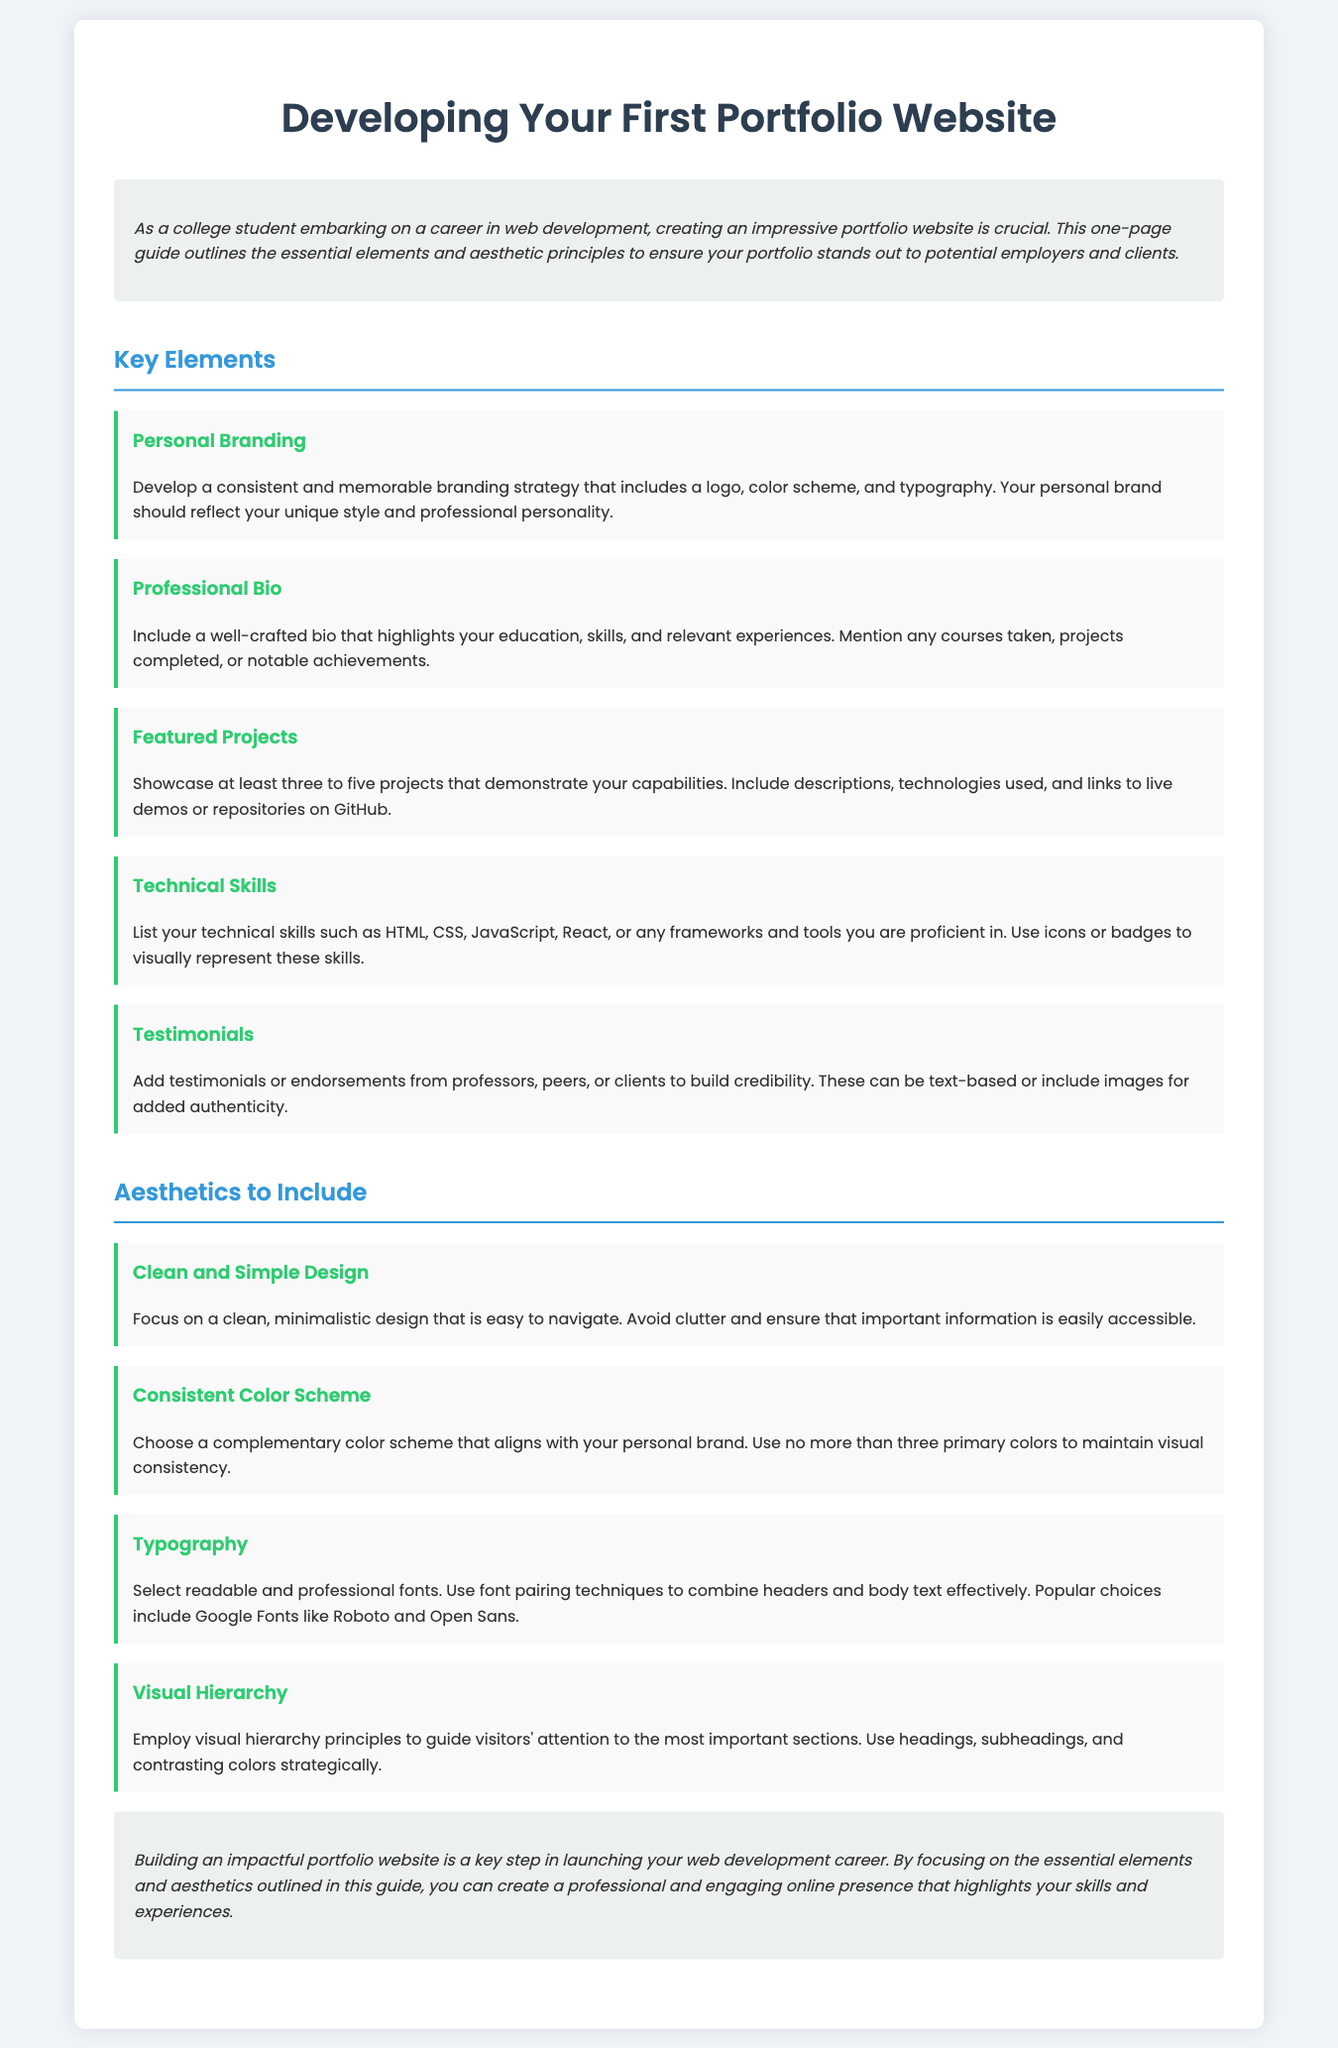What is the main focus of the guide? The main focus is to outline the essential elements and aesthetic principles for creating a portfolio website.
Answer: Essential elements and aesthetic principles How many featured projects should be showcased? The document specifies showcasing at least three to five projects.
Answer: Three to five projects What is included in a professional bio? A professional bio should highlight education, skills, and relevant experiences.
Answer: Education, skills, and relevant experiences What is a key aesthetic mentioned for portfolio design? A key aesthetic mentioned is a clean and simple design.
Answer: Clean and simple design Which color scheme should be chosen? A consistent color scheme that aligns with your personal brand should be chosen.
Answer: Consistent color scheme What element helps build credibility in a portfolio? Testimonials or endorsements help build credibility in a portfolio.
Answer: Testimonials or endorsements What font pairing techniques are suggested? The document suggests using readable and professional fonts with effective font pairing.
Answer: Effective font pairing What is the role of visual hierarchy in web design? Visual hierarchy guides visitors' attention to the most important sections.
Answer: Guides visitors' attention What should be avoided in design according to the guide? The guide advises avoiding clutter in the design.
Answer: Clutter 